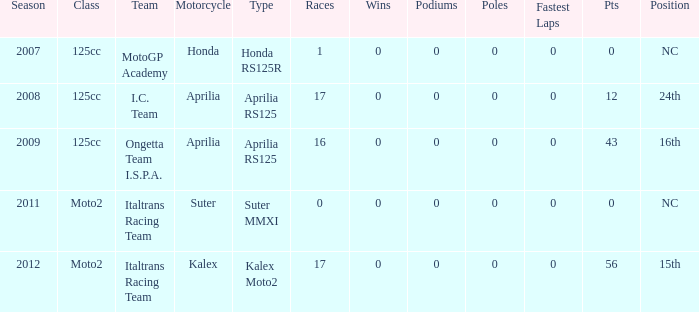What is the count of fastest laps held by i.c. team? 1.0. 